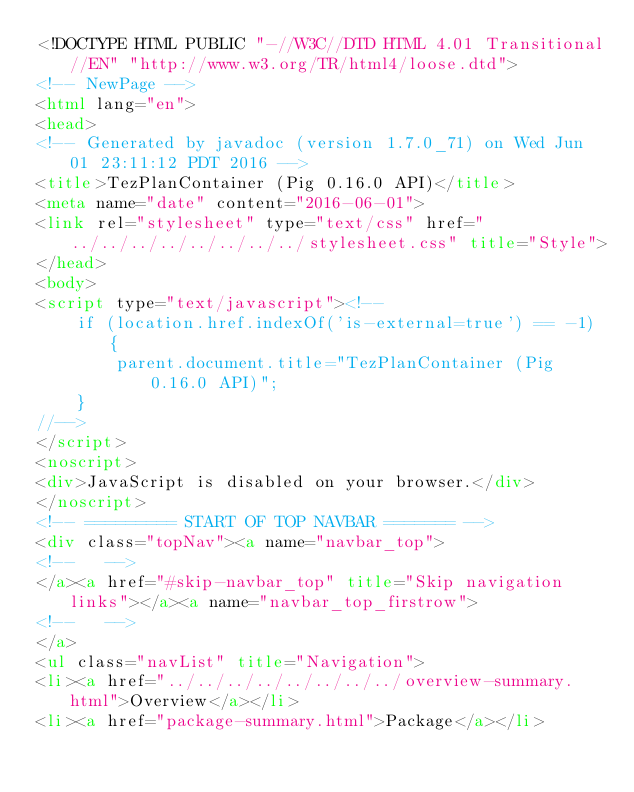Convert code to text. <code><loc_0><loc_0><loc_500><loc_500><_HTML_><!DOCTYPE HTML PUBLIC "-//W3C//DTD HTML 4.01 Transitional//EN" "http://www.w3.org/TR/html4/loose.dtd">
<!-- NewPage -->
<html lang="en">
<head>
<!-- Generated by javadoc (version 1.7.0_71) on Wed Jun 01 23:11:12 PDT 2016 -->
<title>TezPlanContainer (Pig 0.16.0 API)</title>
<meta name="date" content="2016-06-01">
<link rel="stylesheet" type="text/css" href="../../../../../../../../stylesheet.css" title="Style">
</head>
<body>
<script type="text/javascript"><!--
    if (location.href.indexOf('is-external=true') == -1) {
        parent.document.title="TezPlanContainer (Pig 0.16.0 API)";
    }
//-->
</script>
<noscript>
<div>JavaScript is disabled on your browser.</div>
</noscript>
<!-- ========= START OF TOP NAVBAR ======= -->
<div class="topNav"><a name="navbar_top">
<!--   -->
</a><a href="#skip-navbar_top" title="Skip navigation links"></a><a name="navbar_top_firstrow">
<!--   -->
</a>
<ul class="navList" title="Navigation">
<li><a href="../../../../../../../../overview-summary.html">Overview</a></li>
<li><a href="package-summary.html">Package</a></li></code> 